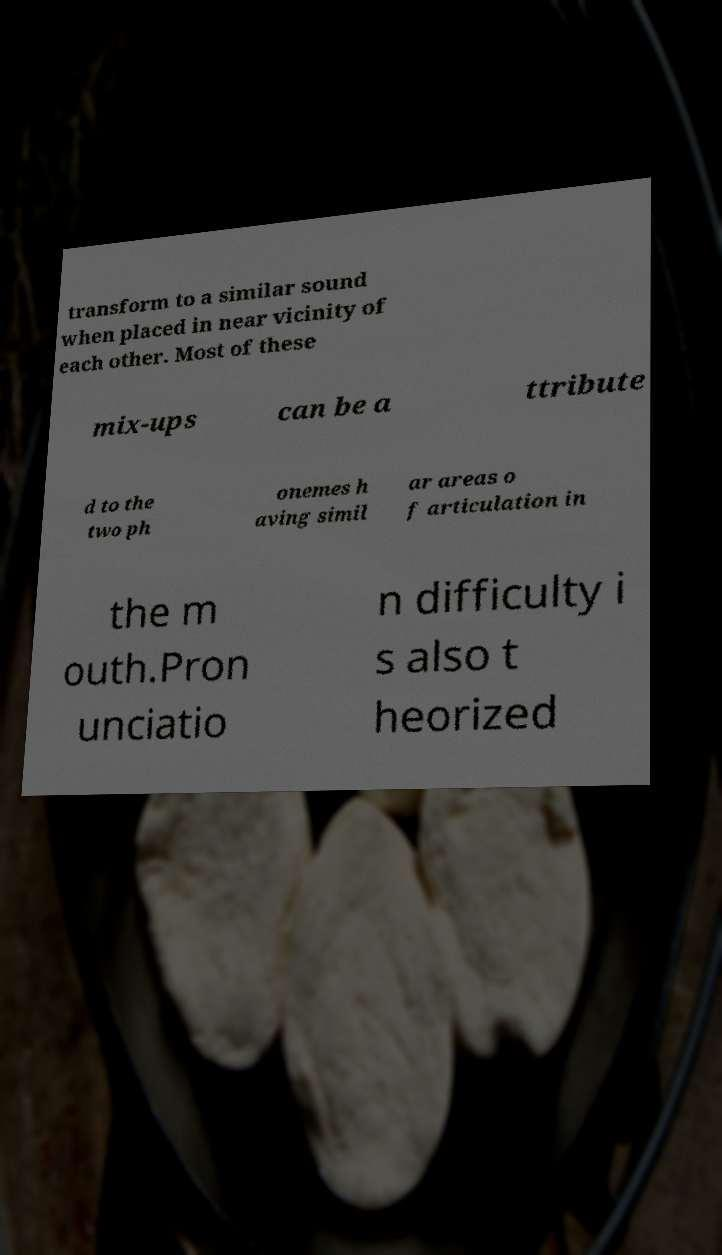Can you accurately transcribe the text from the provided image for me? transform to a similar sound when placed in near vicinity of each other. Most of these mix-ups can be a ttribute d to the two ph onemes h aving simil ar areas o f articulation in the m outh.Pron unciatio n difficulty i s also t heorized 